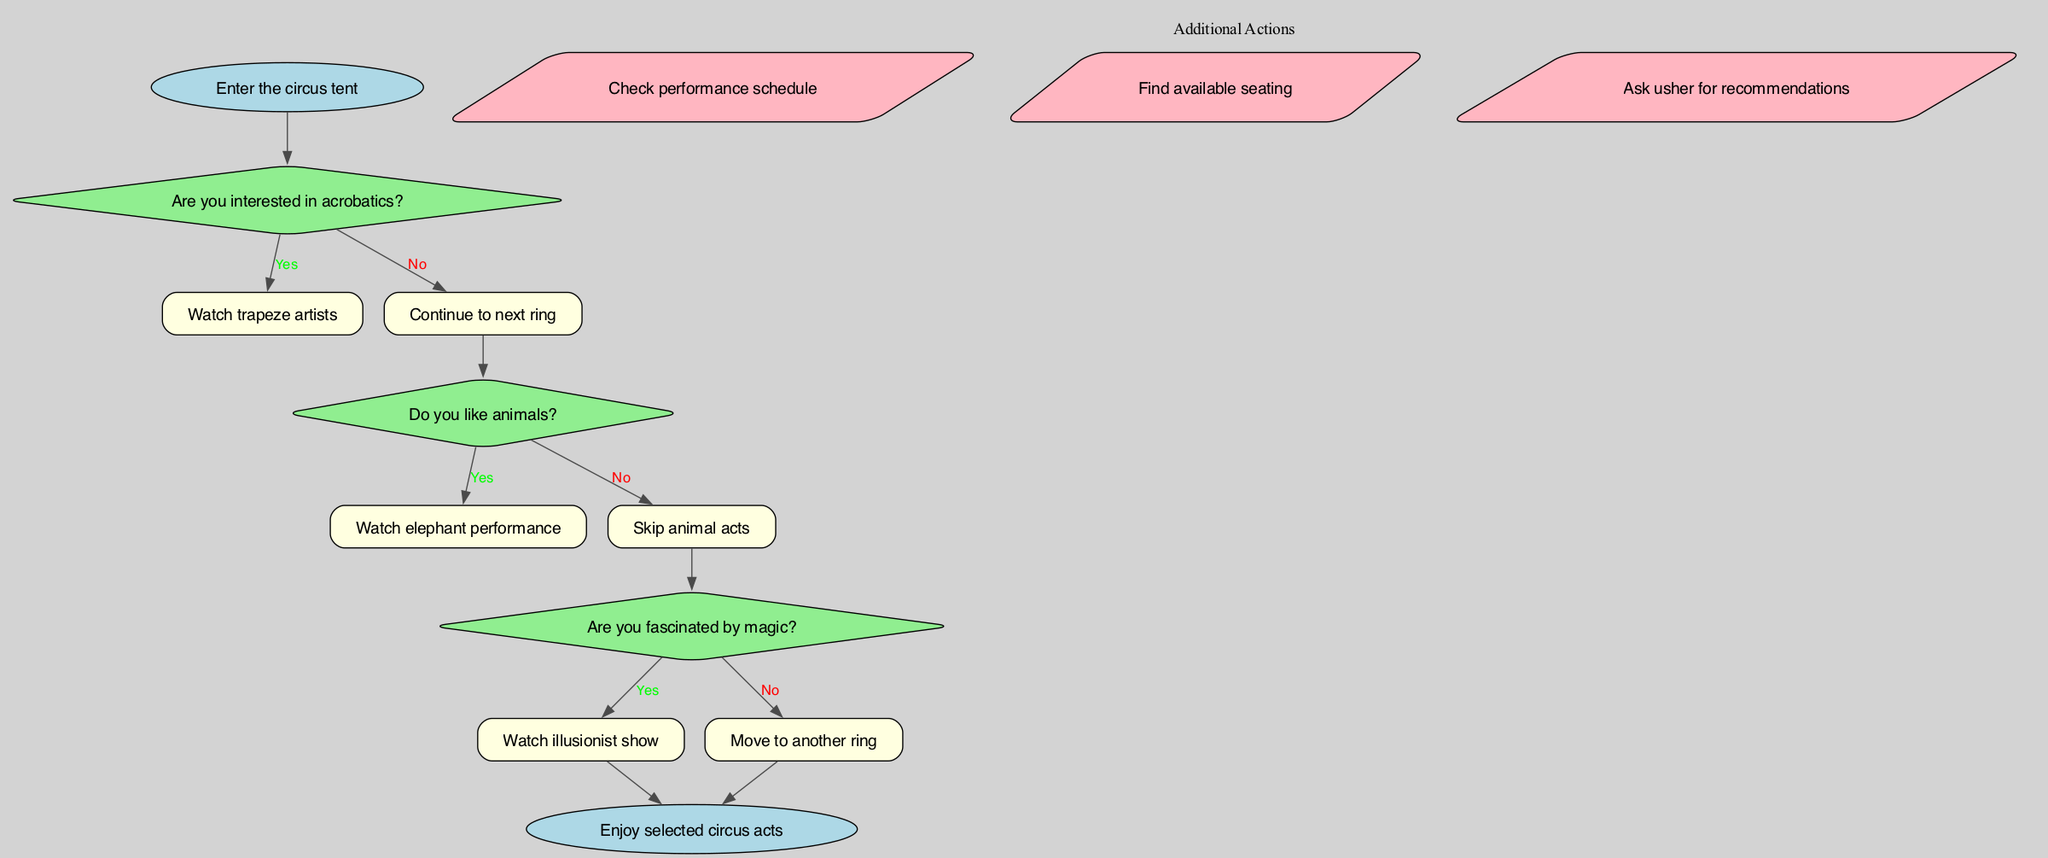What is the first question you encounter? The first decision point after entering the circus tent is about whether you are interested in acrobatics. This is clear from the start node pointing to the first decision node.
Answer: Are you interested in acrobatics? How many decision points are in the diagram? The diagram contains three decision points, each one asking about different interests related to the circus acts, as listed in the data.
Answer: 3 What action can you take after skipping animal acts? If you choose to skip animal acts based on the second decision point, you can move to the third decision point, which asks about your interest in magic. This is evident from the flow of the diagram.
Answer: Move to another ring Which act do you watch if you answer yes to liking animals? If you express interest in animals by answering yes at the second decision point, you will proceed to watch the elephant performance, as stated in the diagram.
Answer: Watch elephant performance What is the final action in the flow chart? The final outcome depicted in the diagram is to enjoy the selected circus acts, which is represented by the end node connected to the last decision points.
Answer: Enjoy selected circus acts What happens if you answer no to all decision points? If you answer no to all decision points, you will still reach the end node, but this means you bypass all acts and may not have selected any specific performance to watch.
Answer: Enjoy selected circus acts 